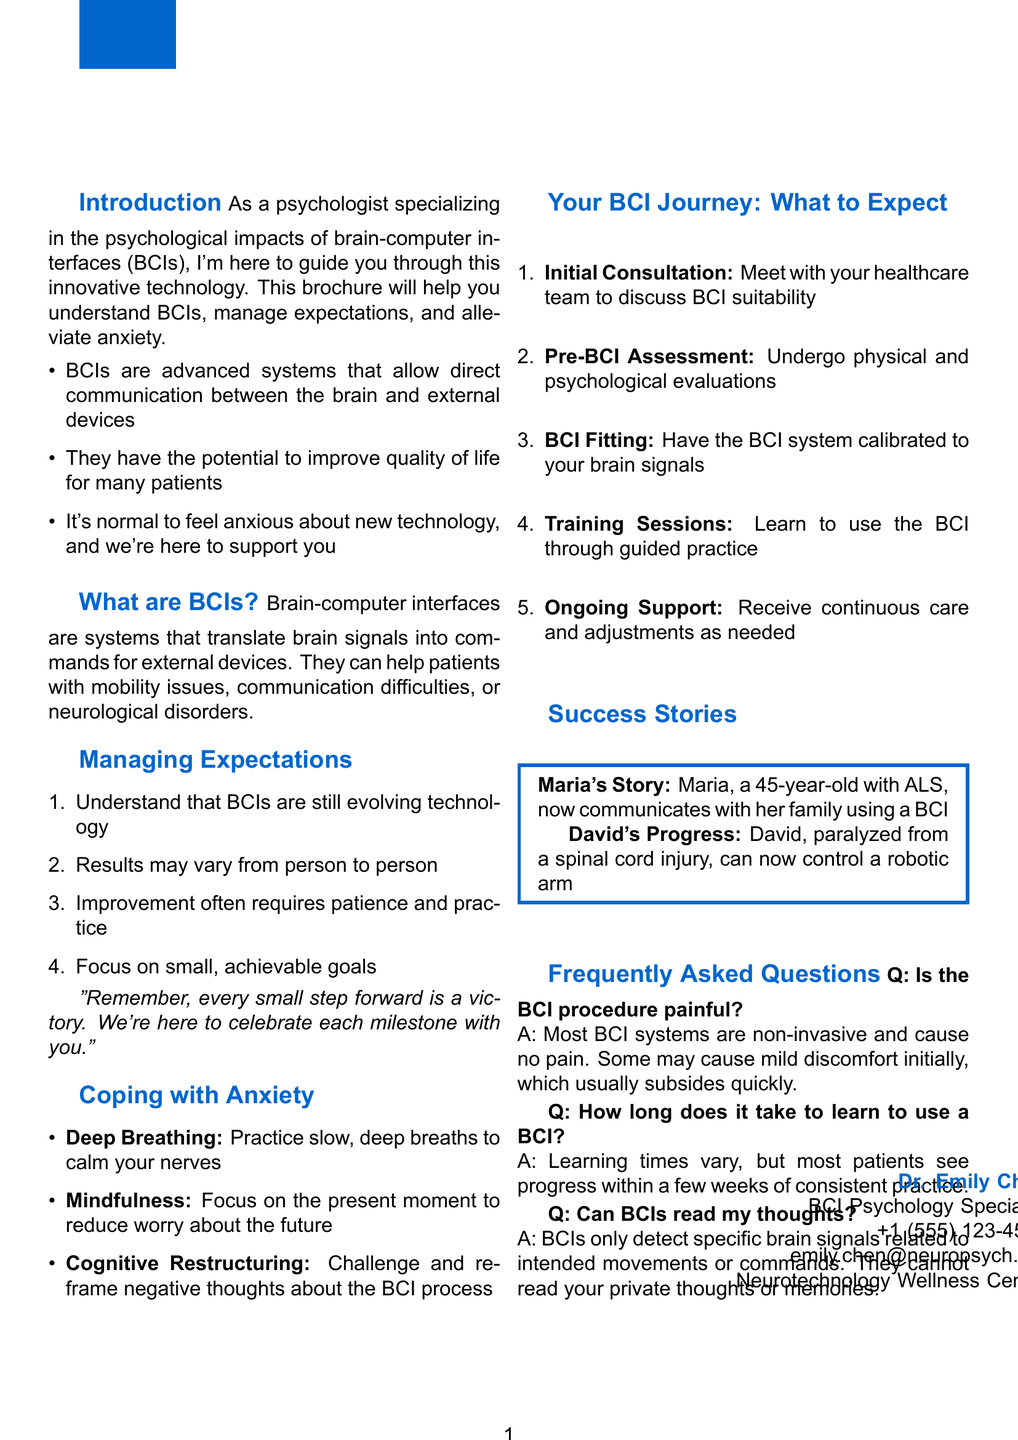What is the title of the brochure? The title of the brochure is provided in the document's header section.
Answer: Understanding Brain-Computer Interfaces: A Guide for Patients Who is the BCI Psychology Specialist? The document includes contact information for the specialist at the bottom.
Answer: Dr. Emily Chen What is one technique for coping with anxiety? The brochure lists various techniques to manage anxiety within a specific section.
Answer: Deep Breathing How many steps are included in the 'Your BCI Journey: What to Expect' section? The document provides a list of steps related to the BCI process.
Answer: Five What should patients focus on when managing expectations? The brochure emphasizes a specific approach in the expectations section.
Answer: Small, achievable goals What type of patients can benefit from BCIs? The document outlines the potential patient population for BCIs based on descriptions given.
Answer: Patients with mobility issues How long do most patients take to see progress with BCIs? The brochure mentions a typical timeframe for improvement in learning to use BCIs.
Answer: A few weeks What is the possible discomfort during the BCI procedure? The brochure addresses common concerns about the procedure in the FAQs section.
Answer: Mild discomfort What does the success story of Maria highlight? The document highlights patient experiences that showcase the effectiveness of BCIs.
Answer: Communication with family 